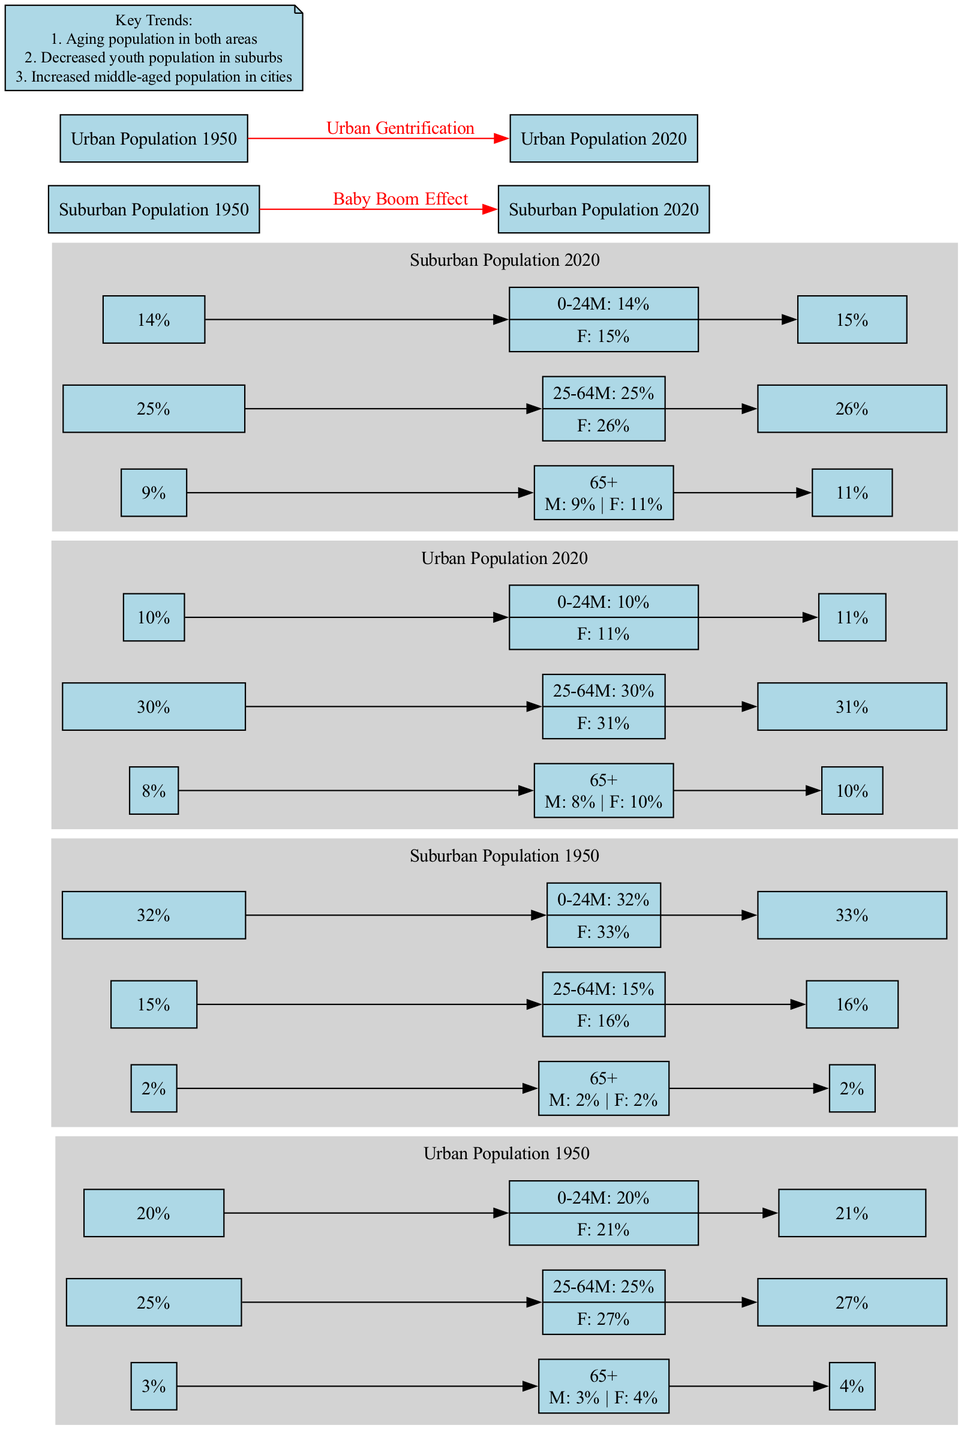What is the male percentage of the 0-24 age group in the Urban Population in 1950? The diagram shows that for the 0-24 age group in the Urban Population in 1950, the male percentage is indicated as 20%.
Answer: 20% What is the total number of edges in the diagram? The diagram contains one edge for each connection represented by arrows plus the edges connecting the nodes of each population pyramid. There are two pyramids for each year, and the total connections between the male and female percentages sum up to 6 edges, plus 4 arrows for the baby boom and gentrification effects, bringing the total to 10 edges.
Answer: 10 Which age group experienced an increase in percentage from 1950 to 2020 in the Urban Population? The diagram shows that the percentage of the 25-64 age group increased from 25% male and 27% female in 1950 to 30% male and 31% female in 2020, indicating this age group experienced an increase.
Answer: 25-64 What was the number of males in the Suburban Population aged 65+ in 2020? According to the diagram, the Suburban Population in 2020 indicates that the number of males in the 65+ age group is 9%.
Answer: 9% What are the key trends listed in the diagram? The diagram presents three key trends: the aging population in both areas, the decreased youth population in suburbs, and the increased middle-aged population in cities.
Answer: Aging population, decreased youth, increased middle-aged What trend can be inferred about the youth population in suburban areas from 1950 to 2020? The diagram indicates a decrease in the youth population in suburban areas, showing a drop from 32% male and 33% female in 1950 to 14% male and 15% female in 2020, highlighting this trend.
Answer: Decrease Which demographic factor shows a significant increase across both Urban and Suburban populations from 1950 to 2020? The diagram indicates an increase in the age group of 65+, which grew from 3 male and 4 female in the Urban Population in 1950 to 8 male and 10 female in 2020, and from 2 male and 2 female in the Suburban Population in 1950 to 9 male and 11 female in 2020.
Answer: Aging population What demographic shift does the arrow labeled "Baby Boom Effect" represent in the Suburban Population? The arrow labeled "Baby Boom Effect" indicates the transition in the Suburban Population from 1950 to 2020, reflecting a growth trend particularly in the older age groups and signifying demographic changes stemming from historical events.
Answer: Growth trend in older age groups 